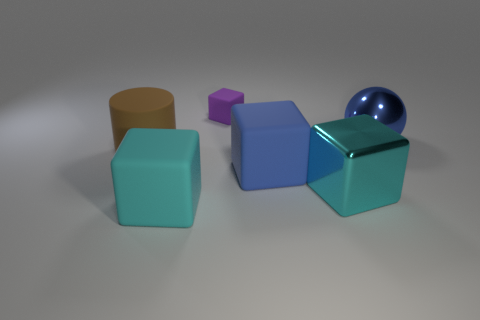Subtract all big cubes. How many cubes are left? 1 Add 2 big purple cylinders. How many objects exist? 8 Subtract all blue cubes. How many cubes are left? 3 Subtract all red balls. How many cyan blocks are left? 2 Add 2 large blue rubber things. How many large blue rubber things are left? 3 Add 6 blue objects. How many blue objects exist? 8 Subtract 0 purple balls. How many objects are left? 6 Subtract all blocks. How many objects are left? 2 Subtract all purple cylinders. Subtract all blue blocks. How many cylinders are left? 1 Subtract all blue things. Subtract all blue metal things. How many objects are left? 3 